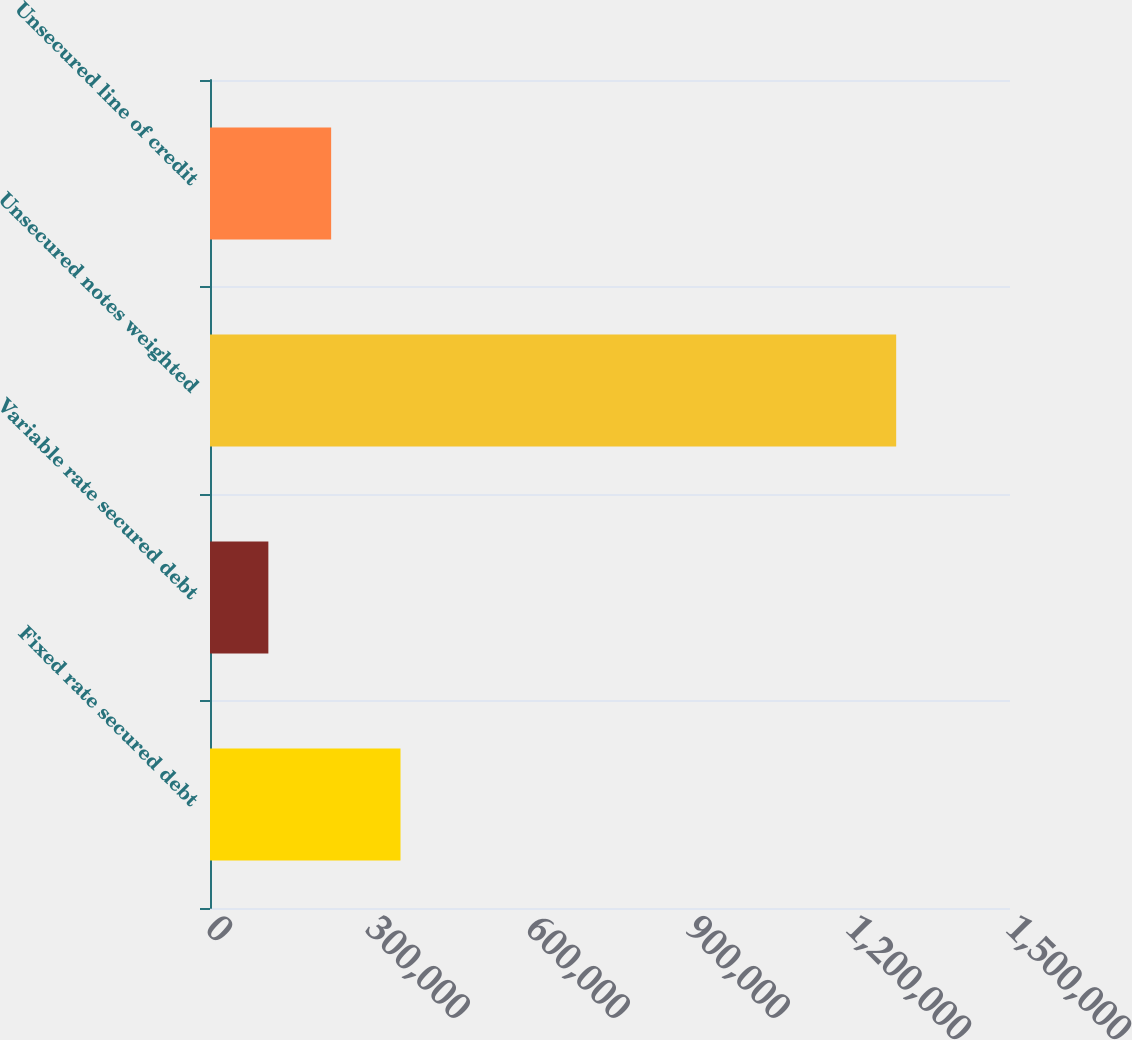Convert chart to OTSL. <chart><loc_0><loc_0><loc_500><loc_500><bar_chart><fcel>Fixed rate secured debt<fcel>Variable rate secured debt<fcel>Unsecured notes weighted<fcel>Unsecured line of credit<nl><fcel>357199<fcel>109425<fcel>1.28659e+06<fcel>227142<nl></chart> 